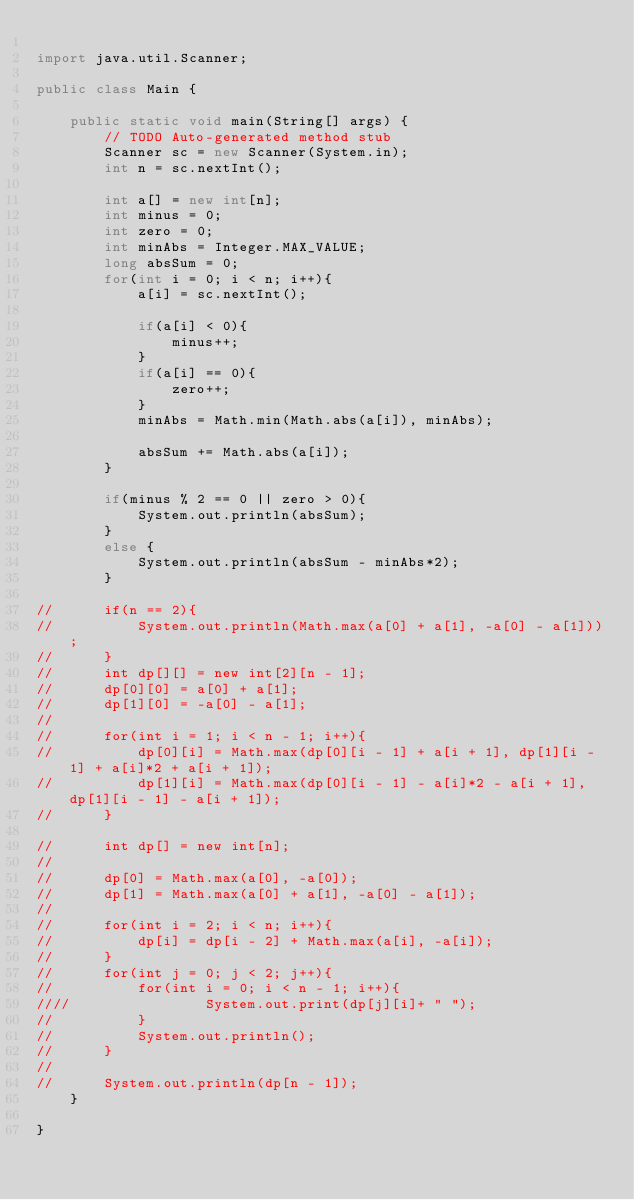<code> <loc_0><loc_0><loc_500><loc_500><_Java_>
import java.util.Scanner;

public class Main {

	public static void main(String[] args) {
		// TODO Auto-generated method stub
		Scanner sc = new Scanner(System.in);
		int n = sc.nextInt();

		int a[] = new int[n];
		int minus = 0;
		int zero = 0;
		int minAbs = Integer.MAX_VALUE;
		long absSum = 0;
		for(int i = 0; i < n; i++){
			a[i] = sc.nextInt();

			if(a[i] < 0){
				minus++;
			}
			if(a[i] == 0){
				zero++;
			}
			minAbs = Math.min(Math.abs(a[i]), minAbs);

			absSum += Math.abs(a[i]);
		}

		if(minus % 2 == 0 || zero > 0){
			System.out.println(absSum);
		}
		else {
			System.out.println(absSum - minAbs*2);
		}

//		if(n == 2){
//			System.out.println(Math.max(a[0] + a[1], -a[0] - a[1]));
//		}
//		int dp[][] = new int[2][n - 1];
//		dp[0][0] = a[0] + a[1];
//		dp[1][0] = -a[0] - a[1];
//
//		for(int i = 1; i < n - 1; i++){
//			dp[0][i] = Math.max(dp[0][i - 1] + a[i + 1], dp[1][i - 1] + a[i]*2 + a[i + 1]);
//			dp[1][i] = Math.max(dp[0][i - 1] - a[i]*2 - a[i + 1], dp[1][i - 1] - a[i + 1]);
//		}

//		int dp[] = new int[n];
//
//		dp[0] = Math.max(a[0], -a[0]);
//		dp[1] = Math.max(a[0] + a[1], -a[0] - a[1]);
//
//		for(int i = 2; i < n; i++){
//			dp[i] = dp[i - 2] + Math.max(a[i], -a[i]);
//		}
//		for(int j = 0; j < 2; j++){
//			for(int i = 0; i < n - 1; i++){
////				System.out.print(dp[j][i]+ " ");
//			}
//			System.out.println();
//		}
//
//		System.out.println(dp[n - 1]);
	}

}</code> 